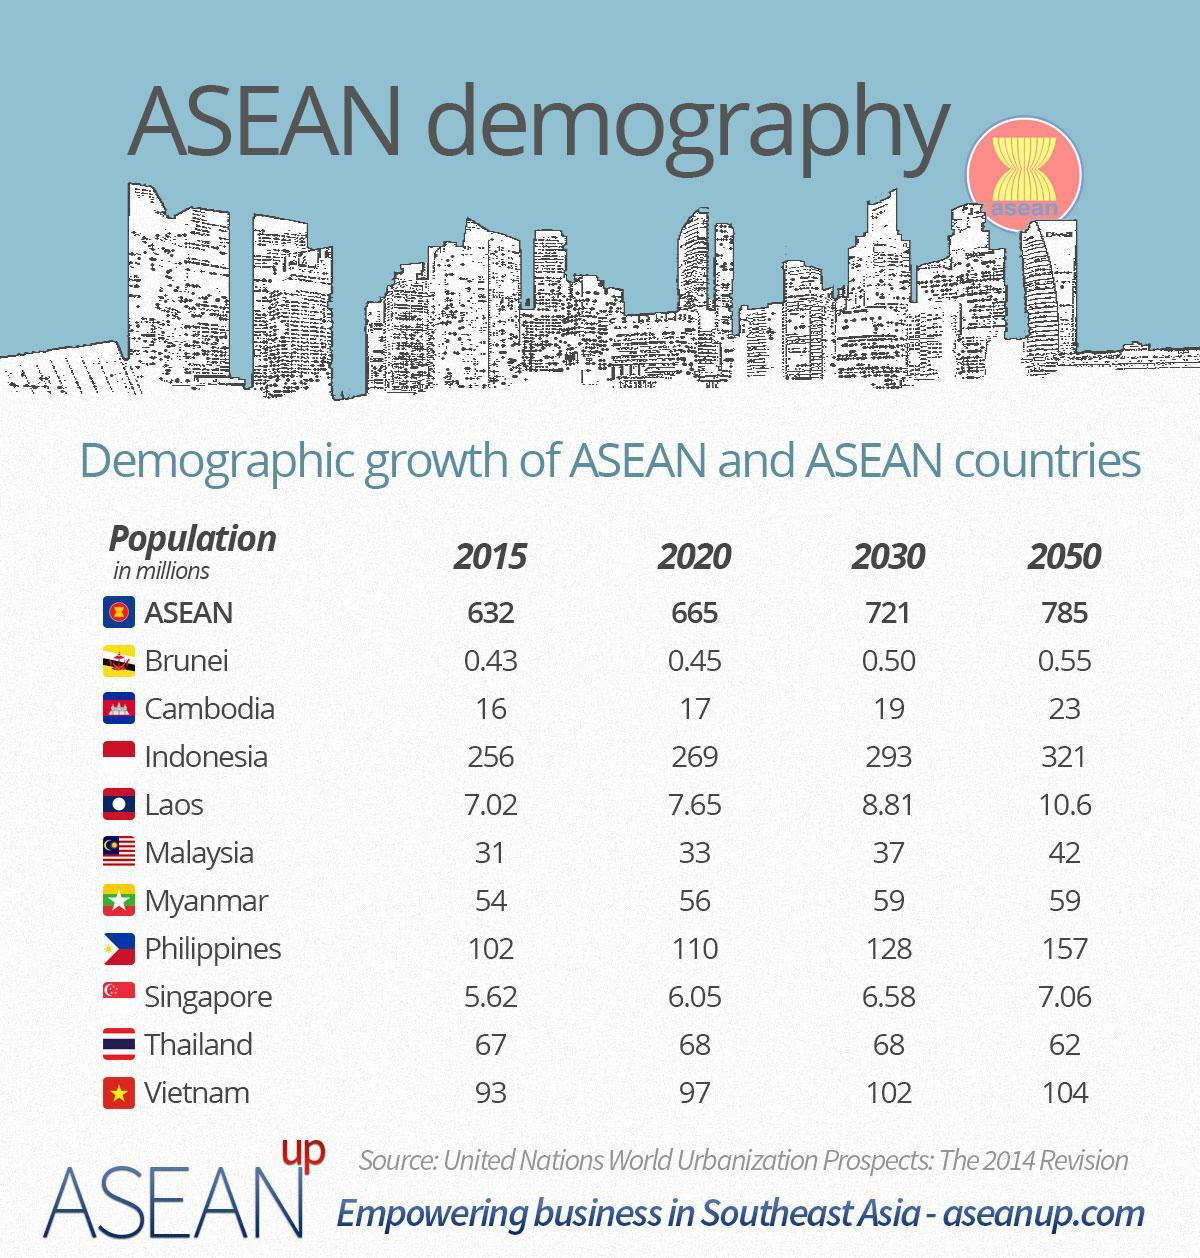Which ASEAN country has the lowest population in 2015?
Answer the question with a short phrase. Brunei What is the population (in millions) of Cambodia in 2020? 17 How many countries are there in ASEAN? 10 Which ASEAN country has the largest population in 2015? Indonesia What is the population (in millions) of Malaysia in 2030? 37 